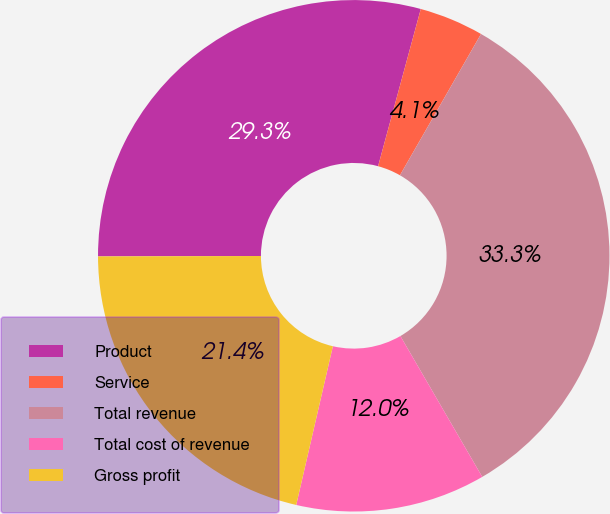Convert chart. <chart><loc_0><loc_0><loc_500><loc_500><pie_chart><fcel>Product<fcel>Service<fcel>Total revenue<fcel>Total cost of revenue<fcel>Gross profit<nl><fcel>29.26%<fcel>4.07%<fcel>33.33%<fcel>11.99%<fcel>21.35%<nl></chart> 